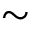<formula> <loc_0><loc_0><loc_500><loc_500>\sim</formula> 